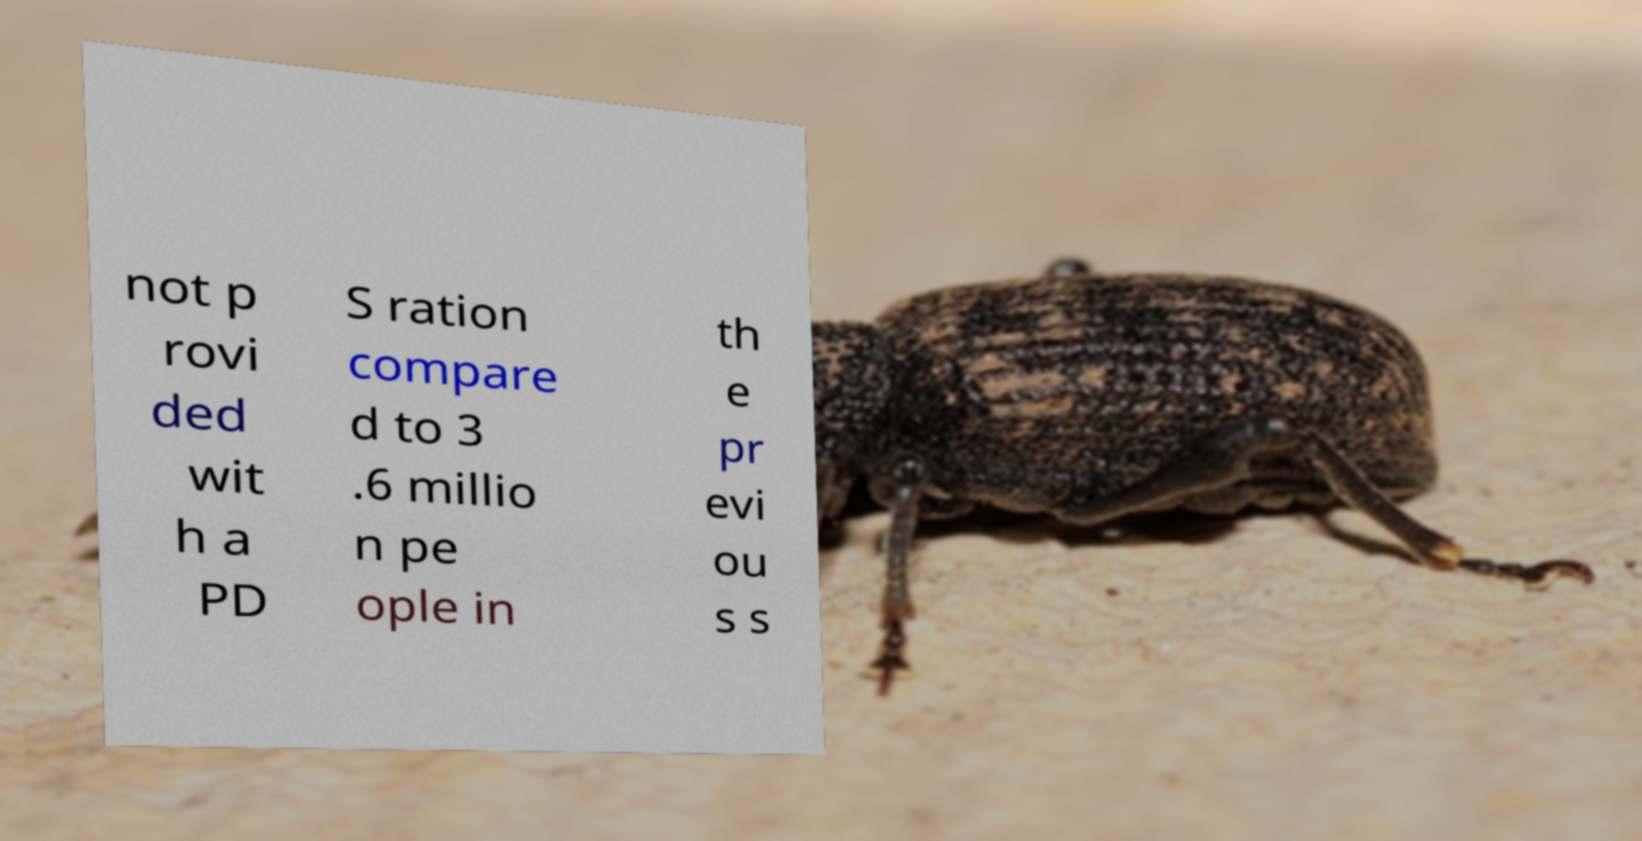I need the written content from this picture converted into text. Can you do that? not p rovi ded wit h a PD S ration compare d to 3 .6 millio n pe ople in th e pr evi ou s s 